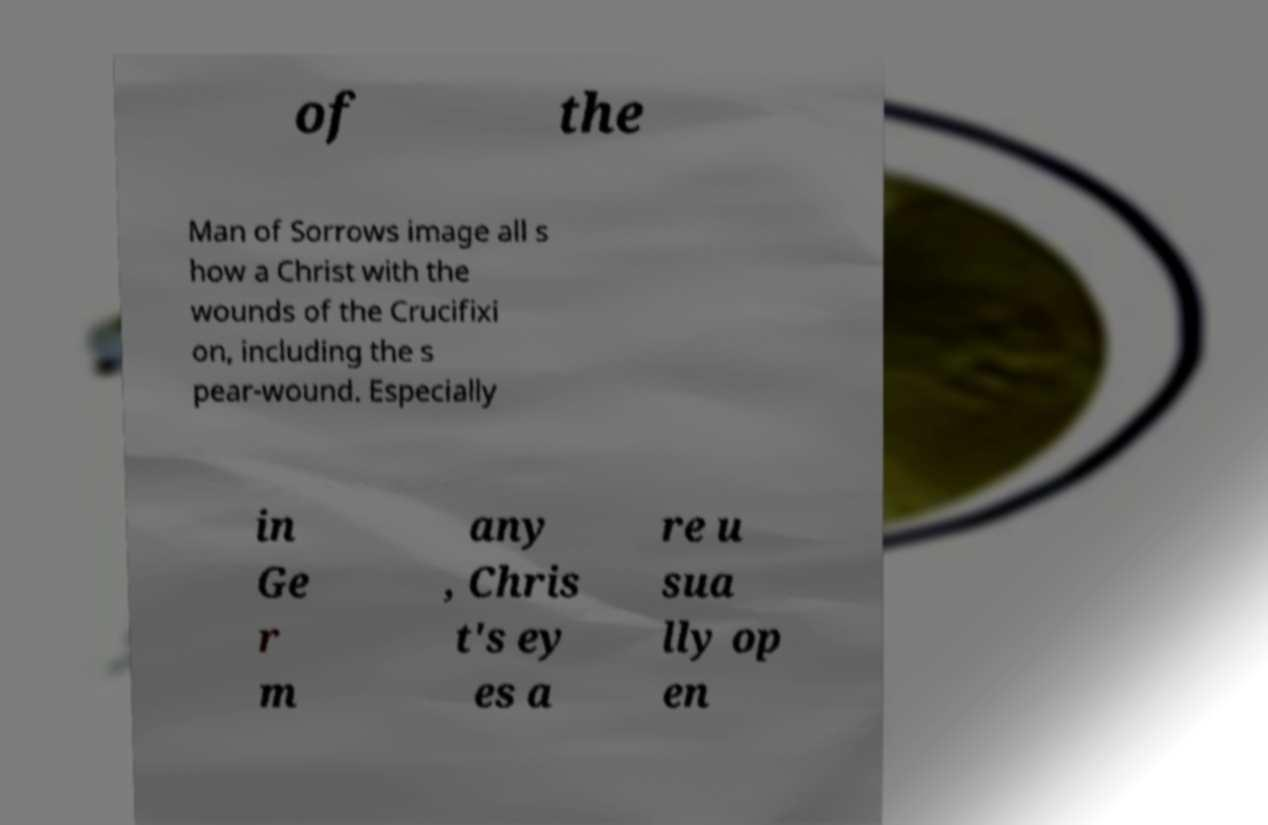Can you read and provide the text displayed in the image?This photo seems to have some interesting text. Can you extract and type it out for me? of the Man of Sorrows image all s how a Christ with the wounds of the Crucifixi on, including the s pear-wound. Especially in Ge r m any , Chris t's ey es a re u sua lly op en 